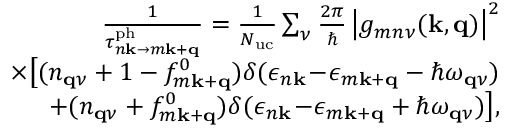Convert formula to latex. <formula><loc_0><loc_0><loc_500><loc_500>\begin{array} { r l r } & { \frac { 1 } { \tau _ { n k \to m k + q } ^ { p h } } = \frac { 1 } { N _ { u c } } \sum _ { \nu } \frac { 2 \pi } { } \left | g _ { m n \nu } ( k , q ) \right | ^ { 2 } } \\ & { \times \left [ ( n _ { q \nu } + 1 - f _ { m k + q } ^ { 0 } ) \delta ( \epsilon _ { n k } \, - \, \epsilon _ { m k + q } - \hbar { \omega } _ { q \nu } ) } \\ & { + ( n _ { q \nu } + f _ { m k + q } ^ { 0 } ) \delta ( \epsilon _ { n k } \, - \, \epsilon _ { m k + q } + \hbar { \omega } _ { q \nu } ) \right ] , } \end{array}</formula> 